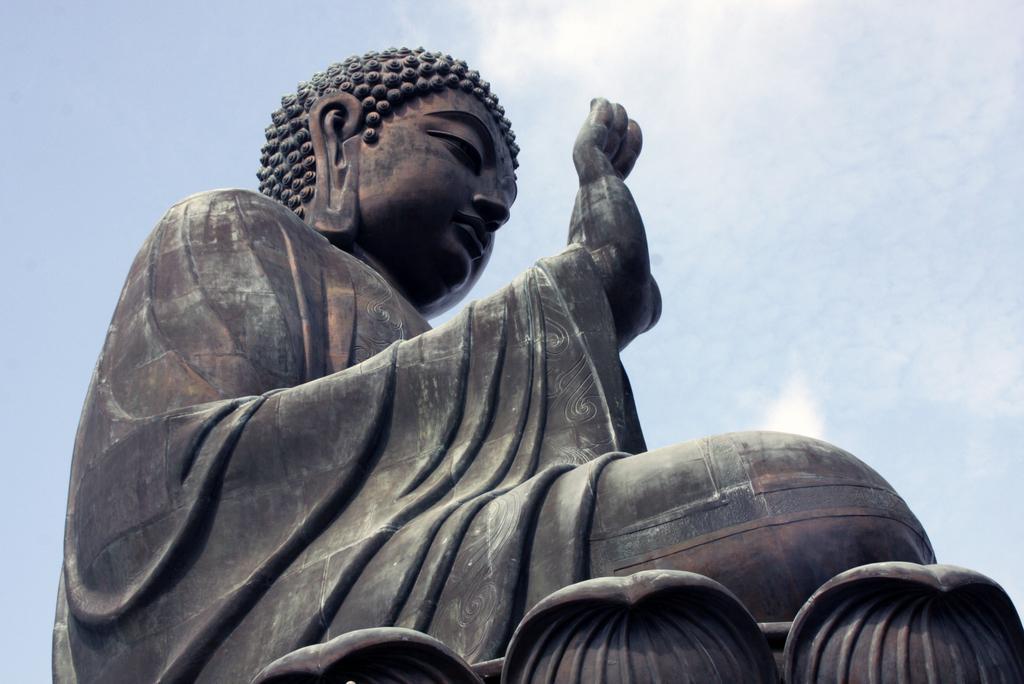Can you describe this image briefly? In this image I can see the statue of Buddha which is in black and brown color. In the background I can see the sky. 